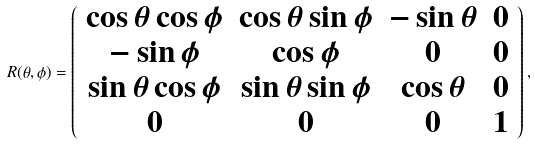<formula> <loc_0><loc_0><loc_500><loc_500>R ( \theta , \phi ) = \left ( \begin{array} { c c c c } \cos \theta \cos \phi & \cos \theta \sin \phi & - \sin \theta & 0 \\ - \sin \phi & \cos \phi & 0 & 0 \\ \sin \theta \cos \phi & \sin \theta \sin \phi & \cos \theta & 0 \\ 0 & 0 & 0 & 1 \\ \end{array} \right ) ,</formula> 